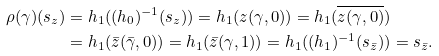<formula> <loc_0><loc_0><loc_500><loc_500>\rho ( \gamma ) ( s _ { z } ) = h _ { 1 } ( ( h _ { 0 } ) ^ { - 1 } ( s _ { z } ) ) = h _ { 1 } ( z ( \gamma , 0 ) ) = h _ { 1 } ( \overline { z ( \gamma , 0 ) } ) & \\ = h _ { 1 } ( \bar { z } ( \bar { \gamma } , 0 ) ) = h _ { 1 } ( \bar { z } ( \gamma , 1 ) ) = h _ { 1 } ( ( h _ { 1 } ) ^ { - 1 } ( s _ { \bar { z } } ) ) & = s _ { \bar { z } } .</formula> 